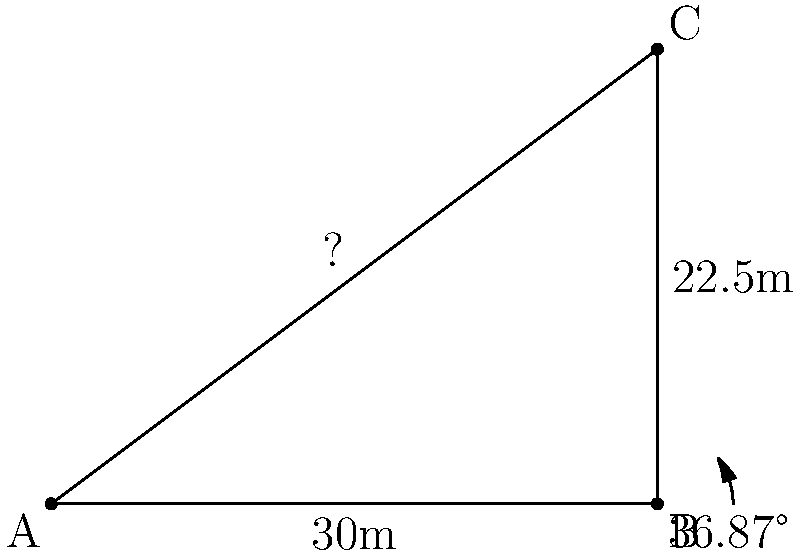For a sweeping shot in your TV series, you need to set up a dolly track from point A to point C. Given that the distance from A to B is 30 meters, and the height of the camera at point C is 22.5 meters, with an angle of 36.87° at point B, calculate the length of the dolly track needed (AC). Round your answer to the nearest centimeter. To solve this problem, we'll use the law of cosines, which is ideal for triangles where we know two sides and the included angle.

The law of cosines states: $c^2 = a^2 + b^2 - 2ab \cos(C)$

Where:
$c$ is the length we're trying to find (AC)
$a$ is the length of AB (30 meters)
$b$ is the length of BC (22.5 meters)
$C$ is the angle at B (36.87°)

Let's plug these values into the formula:

$c^2 = 30^2 + 22.5^2 - 2(30)(22.5) \cos(36.87°)$

Step 1: Calculate the squares
$c^2 = 900 + 506.25 - 1350 \cos(36.87°)$

Step 2: Calculate the cosine
$\cos(36.87°) \approx 0.8$

Step 3: Multiply
$c^2 = 900 + 506.25 - 1350(0.8)$
$c^2 = 900 + 506.25 - 1080$

Step 4: Add and subtract
$c^2 = 326.25$

Step 5: Take the square root
$c = \sqrt{326.25}$
$c \approx 18.0624$ meters

Step 6: Round to the nearest centimeter
$c \approx 18.06$ meters

Therefore, the length of the dolly track needed is approximately 18.06 meters.
Answer: 18.06 meters 